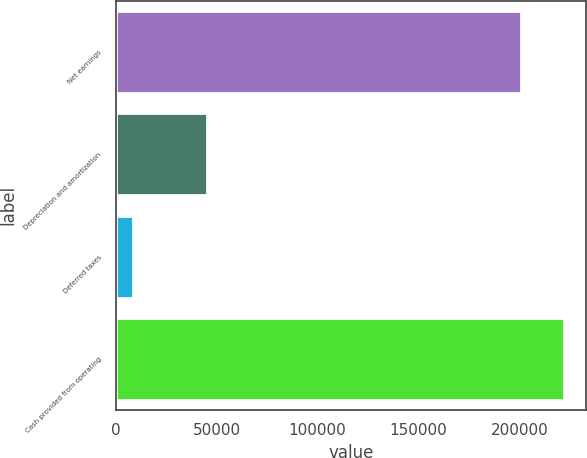<chart> <loc_0><loc_0><loc_500><loc_500><bar_chart><fcel>Net earnings<fcel>Depreciation and amortization<fcel>Deferred taxes<fcel>Cash provided from operating<nl><fcel>200900<fcel>45323<fcel>8756<fcel>221856<nl></chart> 